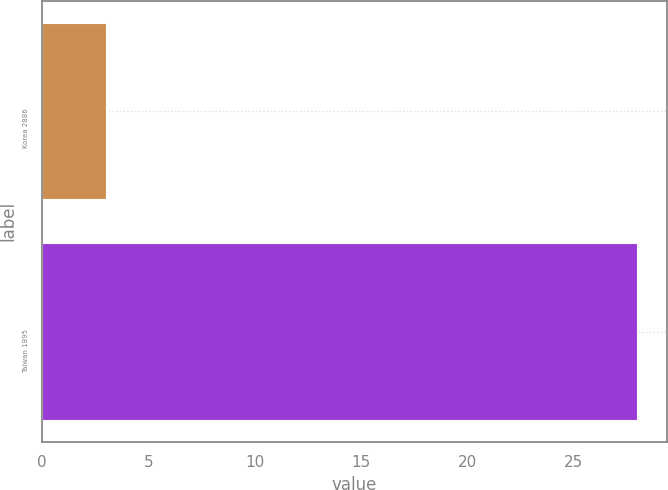Convert chart. <chart><loc_0><loc_0><loc_500><loc_500><bar_chart><fcel>Korea 2886<fcel>Taiwan 1895<nl><fcel>3<fcel>28<nl></chart> 